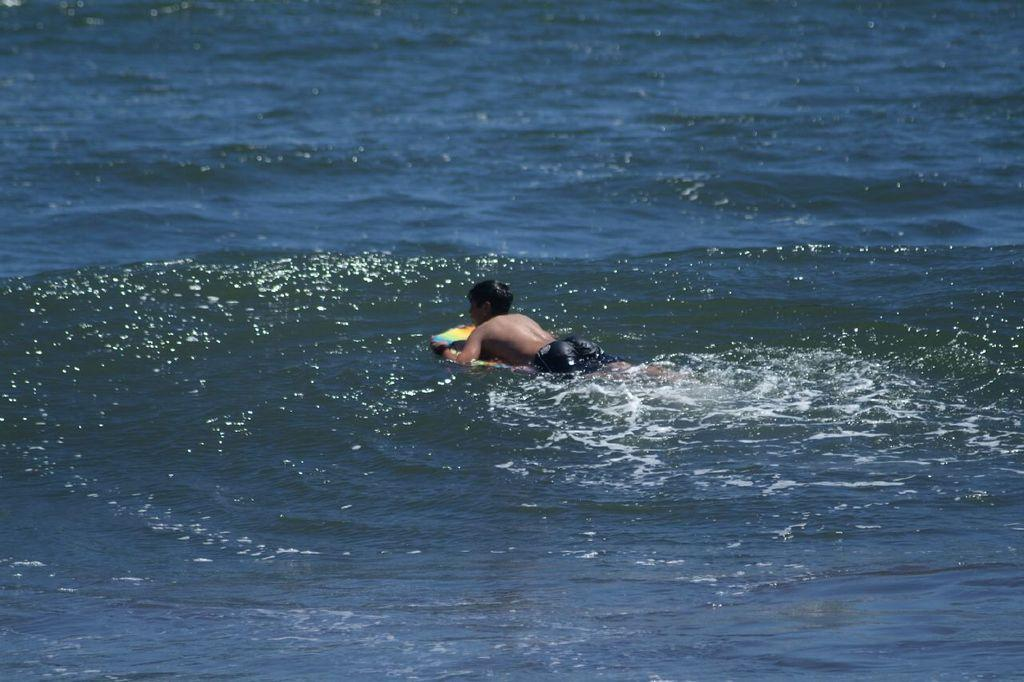What is the main subject of the image? The main subject of the image is a boy. What is the boy doing in the image? The boy is swimming in the water. What type of vessel is the boy using to swim in the image? The image does not show the boy using any vessel to swim; he is swimming without any additional equipment. How much money is the boy holding in the image? There is no money visible in the image; the boy is swimming in the water. 